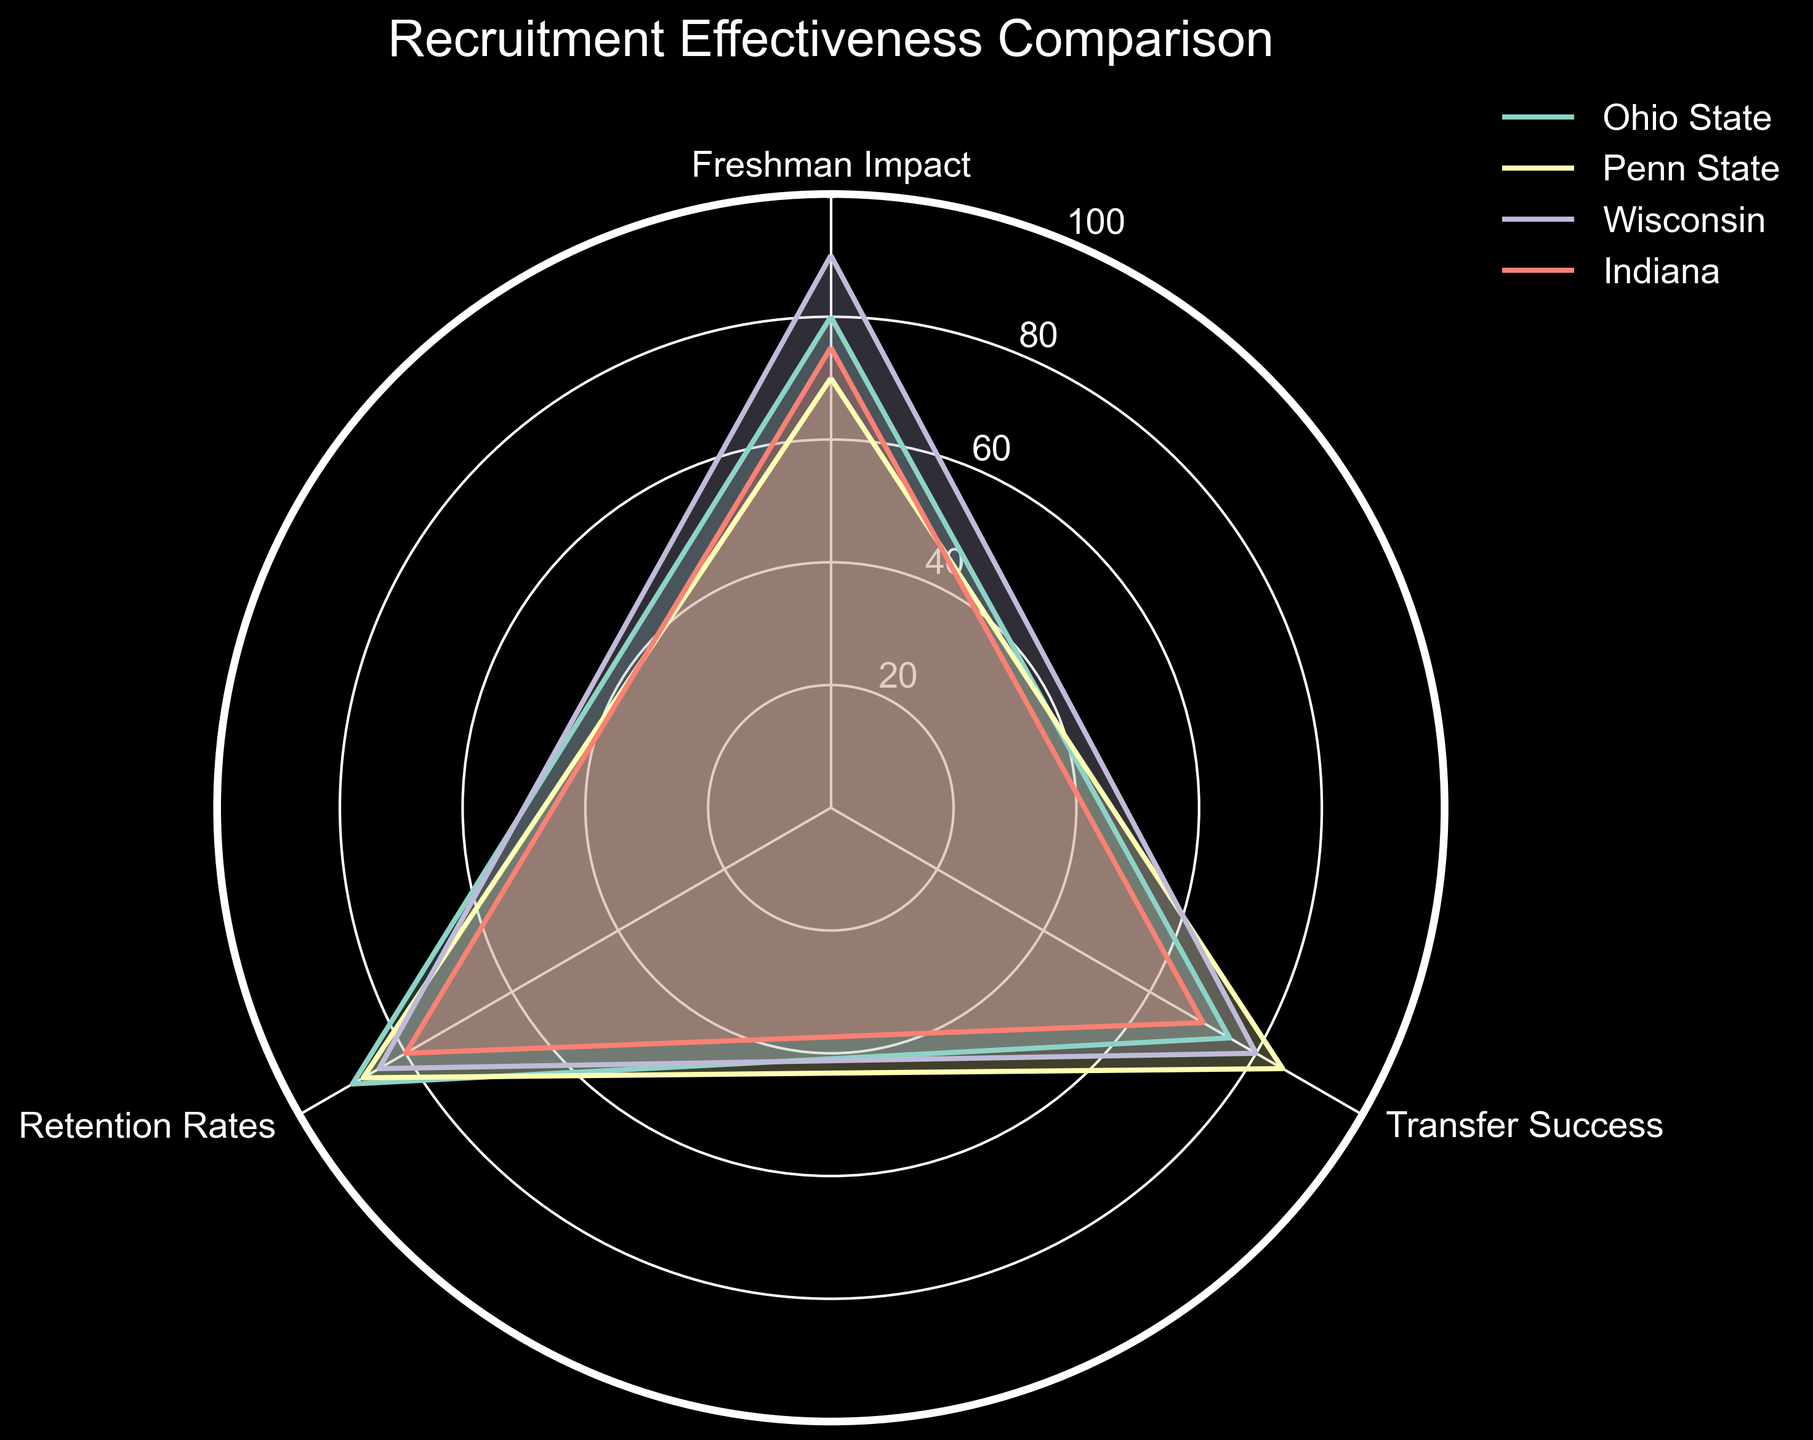Who has the highest Freshman Impact? By examining the plot lines on the Freshman Impact axis, Wisconsin shows the highest value at 90.
Answer: Wisconsin Which team has the lowest Retention Rates? Checking the values on the Retention Rates axis, Indiana has the lowest with a value of 80.
Answer: Indiana What is the average Transfer Success rate across all teams? Add the Transfer Success values (75 + 85 + 80 + 70) and divide by the number of teams (4): (75 + 85 + 80 + 70) / 4 = 77.5.
Answer: 77.5 Which team excels in both Retention Rates and Freshman Impact? Identify the team with high values in both Retention Rates and Freshman Impact. Wisconsin scores high in both categories with 85 and 90, respectively.
Answer: Wisconsin How does Penn State's Freshman Impact compare to Ohio State's Transfer Success? Penn State's Freshman Impact is 70, while Ohio State's Transfer Success is 75. 70 < 75.
Answer: Penn State's Freshman Impact is lower Is there any team that has consistently high ratings across all categories? Analyzing the plot for teams with consistently high points in Freshman Impact, Transfer Success, and Retention Rates, Ohio State stands out with values of 80, 75, and 90, respectively.
Answer: Ohio State What is the combined score of Transfer Success and Retention Rates for Indiana? Adding Indiana's Transfer Success and Retention Rates: 70 + 80 = 150.
Answer: 150 Which teams have a higher Transfer Success than Freshman Impact? By comparing the Transfer Success and Freshman Impact values, Penn State (85 vs 70) and Indiana (70 vs 75) both have higher Transfer Success rates than Freshman Impact.
Answer: Penn State, Indiana Who has the closest Freshman Impact to Indiana? Comparing Freshman Impact values, Ohio State has 80, closest to Indiana's 75.
Answer: Ohio State 